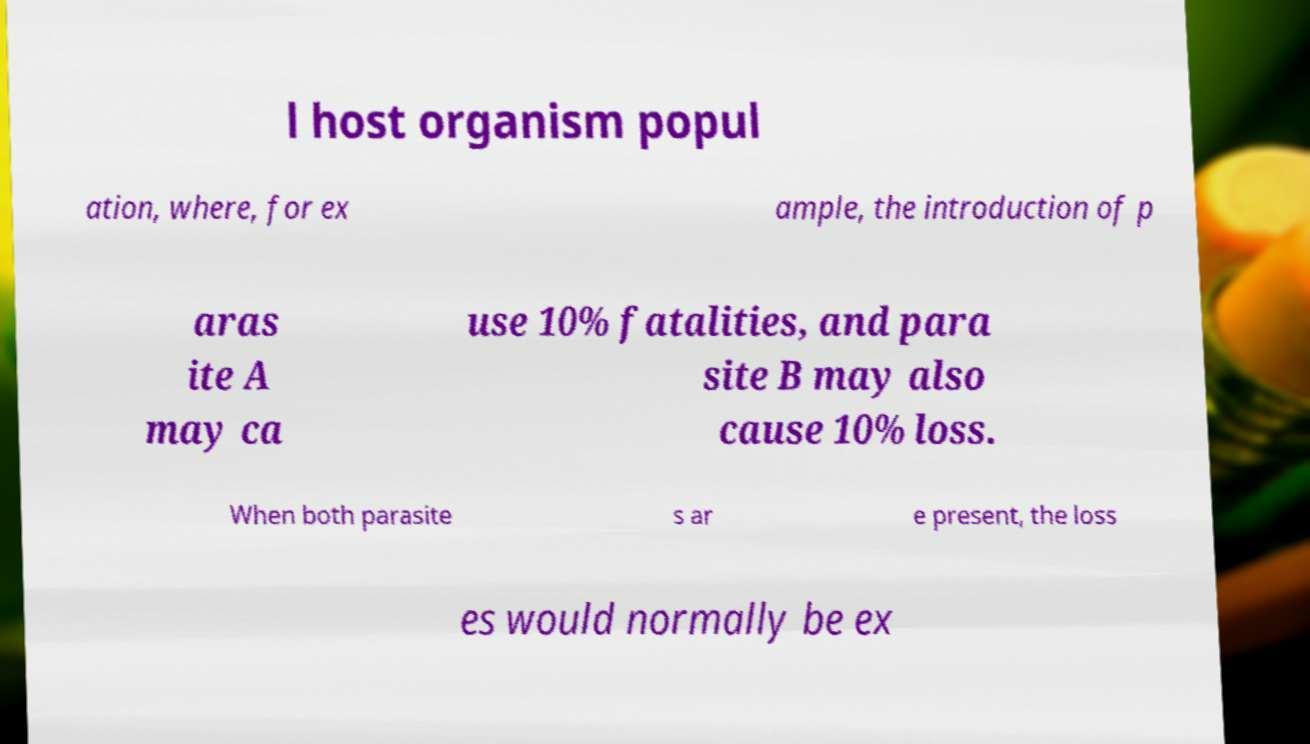Could you extract and type out the text from this image? l host organism popul ation, where, for ex ample, the introduction of p aras ite A may ca use 10% fatalities, and para site B may also cause 10% loss. When both parasite s ar e present, the loss es would normally be ex 